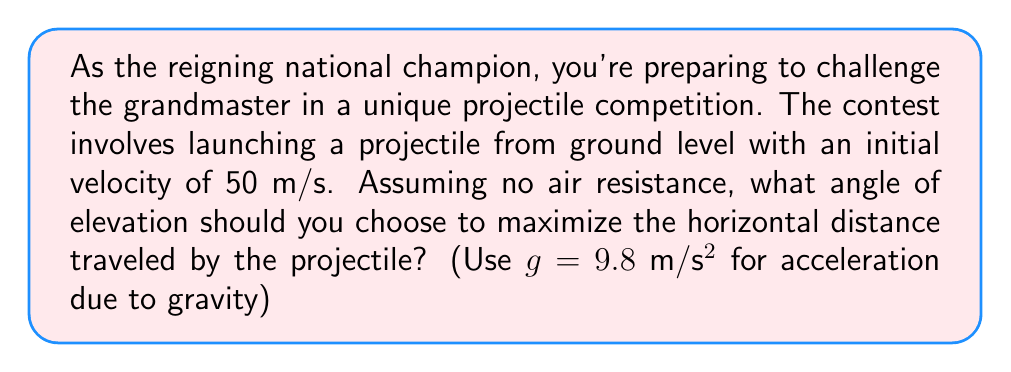Teach me how to tackle this problem. Let's approach this step-by-step:

1) The range (R) of a projectile launched from ground level is given by the equation:

   $$R = \frac{v_0^2 \sin(2\theta)}{g}$$

   Where $v_0$ is the initial velocity, $\theta$ is the angle of elevation, and $g$ is the acceleration due to gravity.

2) To maximize R, we need to maximize $\sin(2\theta)$.

3) The maximum value of sine function is 1, which occurs when its argument is 90°.

4) So, we want:

   $$2\theta = 90°$$

5) Solving for $\theta$:

   $$\theta = 45°$$

6) We can verify this by considering the trigonometric identity:

   $$\sin(2\theta) = 2\sin(\theta)\cos(\theta)$$

   At 45°, $\sin(\theta) = \cos(\theta) = \frac{1}{\sqrt{2}}$, so:

   $$\sin(2 \cdot 45°) = 2 \cdot \frac{1}{\sqrt{2}} \cdot \frac{1}{\sqrt{2}} = 1$$

   Which is indeed the maximum value.

7) Therefore, to achieve maximum range, you should launch the projectile at a 45° angle to the horizontal.

[asy]
import geometry;

size(200);
draw((0,0)--(100,0), arrow=Arrow(TeXHead));
draw((0,0)--(0,100), arrow=Arrow(TeXHead));
draw((0,0)--(70,70), arrow=Arrow(TeXHead));
label("45°", (10,10), NE);
label("x", (100,0), S);
label("y", (0,100), W);
label("v₀", (35,35), NW);
[/asy]
Answer: 45° 